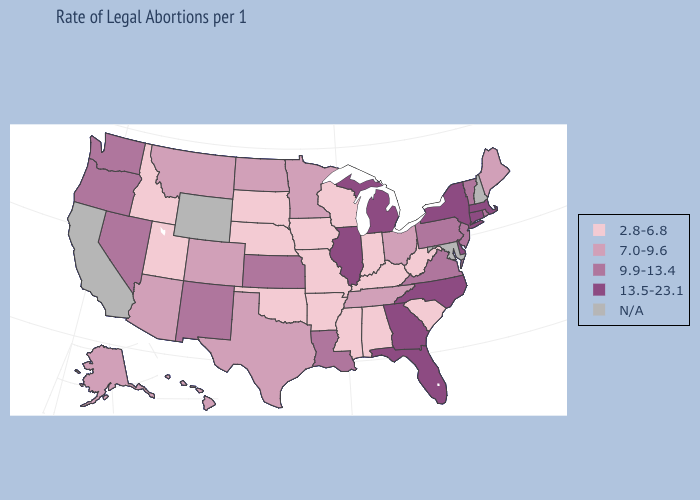Among the states that border Mississippi , does Alabama have the lowest value?
Keep it brief. Yes. Does the map have missing data?
Write a very short answer. Yes. What is the lowest value in the South?
Quick response, please. 2.8-6.8. Name the states that have a value in the range N/A?
Write a very short answer. California, Maryland, New Hampshire, Wyoming. Does Maine have the lowest value in the USA?
Quick response, please. No. What is the highest value in the South ?
Answer briefly. 13.5-23.1. Which states have the lowest value in the MidWest?
Be succinct. Indiana, Iowa, Missouri, Nebraska, South Dakota, Wisconsin. Name the states that have a value in the range 13.5-23.1?
Short answer required. Connecticut, Delaware, Florida, Georgia, Illinois, Massachusetts, Michigan, New York, North Carolina. Name the states that have a value in the range 9.9-13.4?
Short answer required. Kansas, Louisiana, Nevada, New Jersey, New Mexico, Oregon, Pennsylvania, Rhode Island, Vermont, Virginia, Washington. Among the states that border California , does Arizona have the lowest value?
Concise answer only. Yes. Which states hav the highest value in the West?
Be succinct. Nevada, New Mexico, Oregon, Washington. Among the states that border Rhode Island , which have the lowest value?
Answer briefly. Connecticut, Massachusetts. What is the value of Rhode Island?
Give a very brief answer. 9.9-13.4. What is the value of Maryland?
Answer briefly. N/A. 